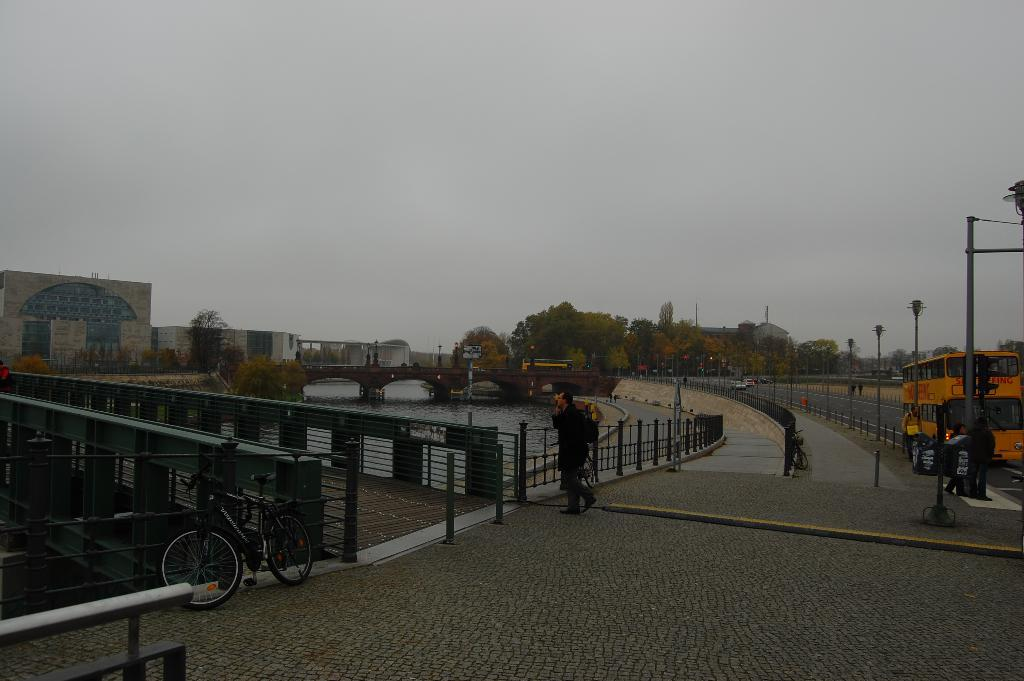What types of transportation can be seen in the image? There are vehicles and bicycles in the image. What else can be seen on the ground in the image? There are people on the ground in the image. What structures are present in the image? There are poles, a bridge, and buildings in the image. What type of vegetation is visible in the image? There are trees in the image. What is visible in the background of the image? The sky is visible in the background of the image. What is the comparison between the number of bicycles and the number of afterthoughts in the image? There is no mention of afterthoughts in the image, so it is not possible to make a comparison between the number of bicycles and afterthoughts. What is the limit of the bridge in the image? The image does not provide information about the limit or capacity of the bridge, so it cannot be determined from the image. 